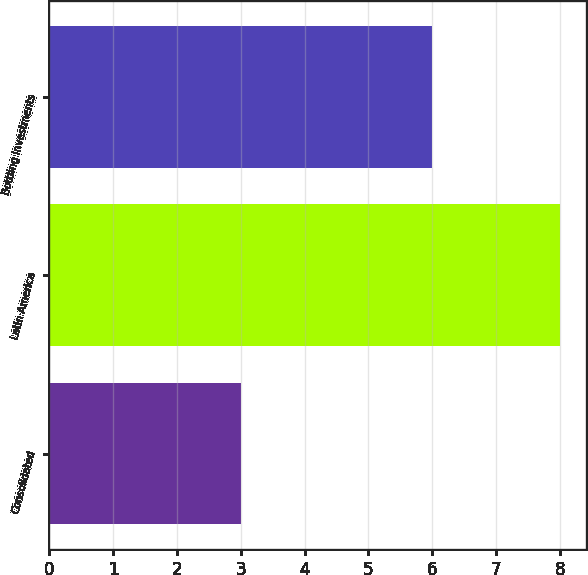Convert chart to OTSL. <chart><loc_0><loc_0><loc_500><loc_500><bar_chart><fcel>Consolidated<fcel>Latin America<fcel>Bottling Investments<nl><fcel>3<fcel>8<fcel>6<nl></chart> 